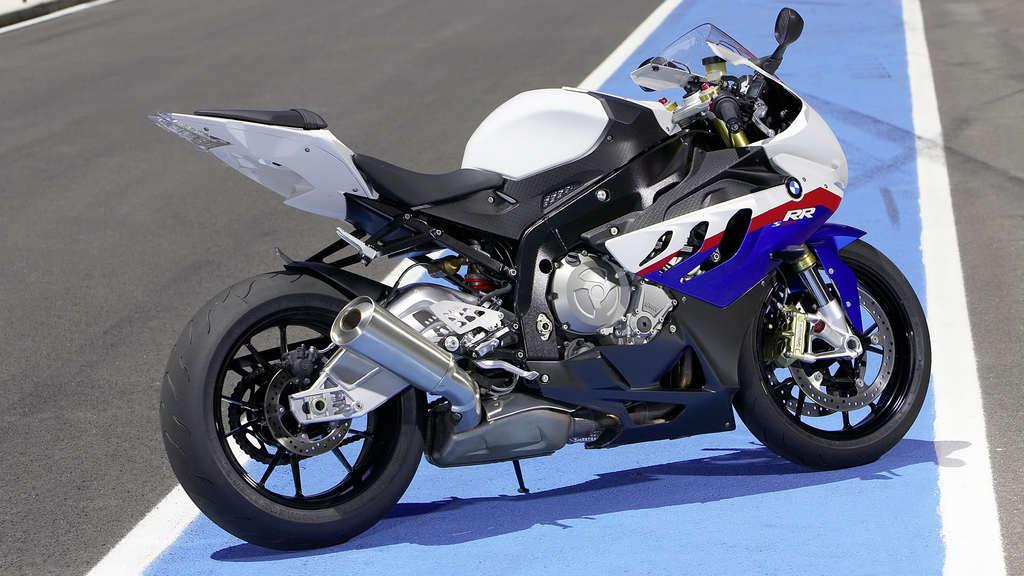What is the main object in the image? There is a bike in the image. How is the bike positioned in the image? The bike is parked on the ground. What can be seen on the ground in the image? There are markings on the ground. What is written or printed on the bike? There is text on the bike. What type of noise can be heard coming from the bike in the image? There is no noise coming from the bike in the image, as it is parked and not in use. What boundary is indicated by the markings on the ground in the image? The provided facts do not mention any boundaries or specific markings on the ground, so it cannot be determined from the image. 